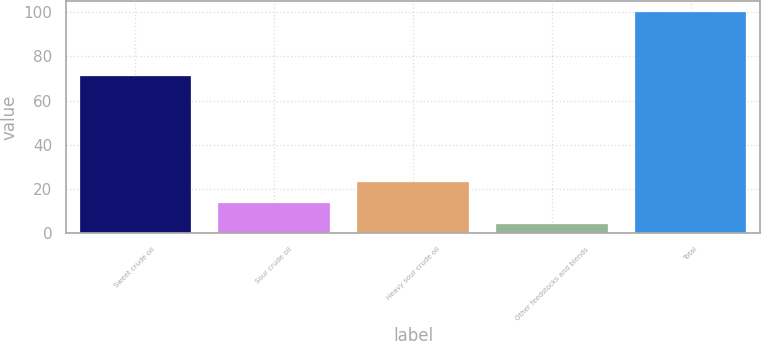<chart> <loc_0><loc_0><loc_500><loc_500><bar_chart><fcel>Sweet crude oil<fcel>Sour crude oil<fcel>Heavy sour crude oil<fcel>Other feedstocks and blends<fcel>Total<nl><fcel>71<fcel>13.6<fcel>23.2<fcel>4<fcel>100<nl></chart> 